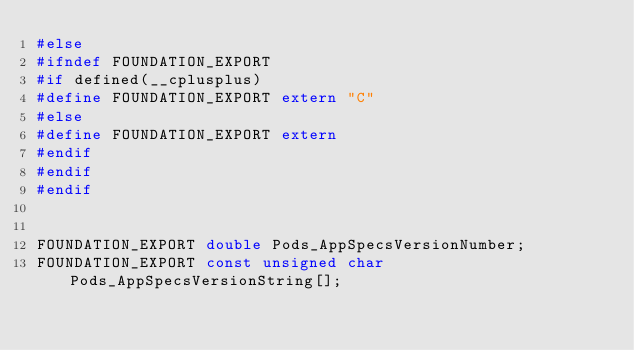<code> <loc_0><loc_0><loc_500><loc_500><_C_>#else
#ifndef FOUNDATION_EXPORT
#if defined(__cplusplus)
#define FOUNDATION_EXPORT extern "C"
#else
#define FOUNDATION_EXPORT extern
#endif
#endif
#endif


FOUNDATION_EXPORT double Pods_AppSpecsVersionNumber;
FOUNDATION_EXPORT const unsigned char Pods_AppSpecsVersionString[];

</code> 